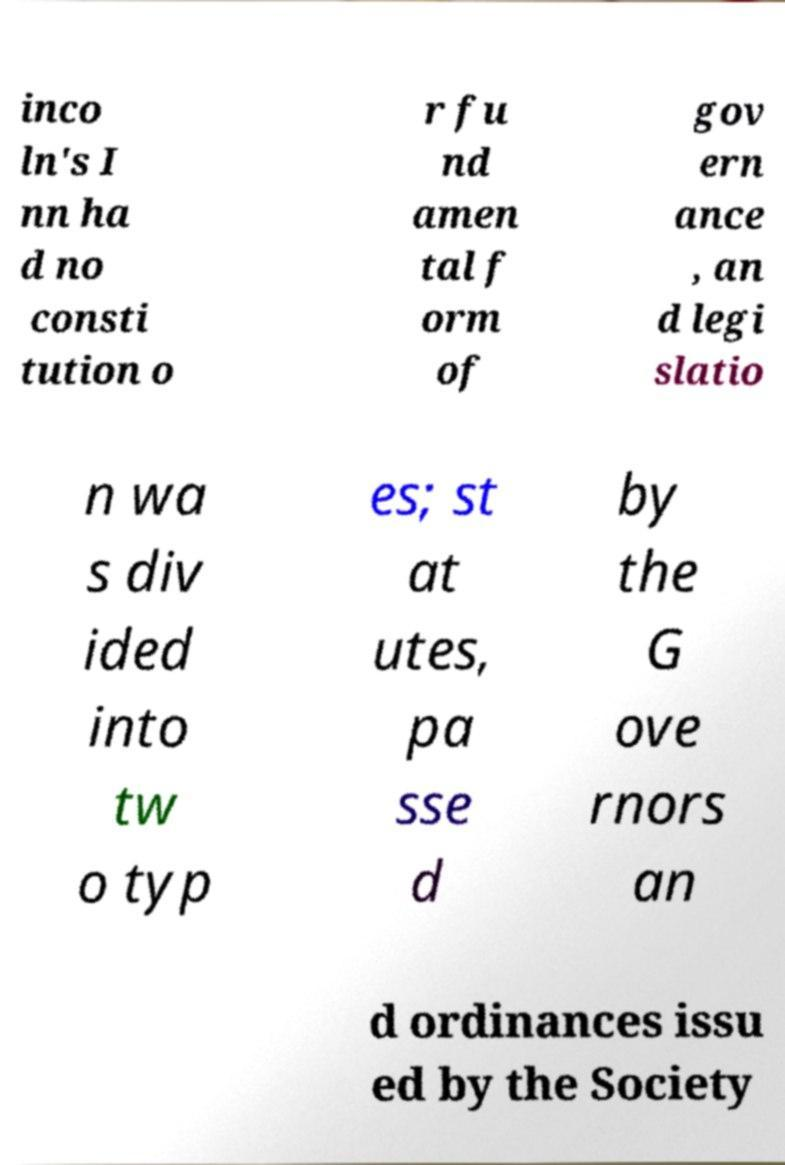Please read and relay the text visible in this image. What does it say? inco ln's I nn ha d no consti tution o r fu nd amen tal f orm of gov ern ance , an d legi slatio n wa s div ided into tw o typ es; st at utes, pa sse d by the G ove rnors an d ordinances issu ed by the Society 